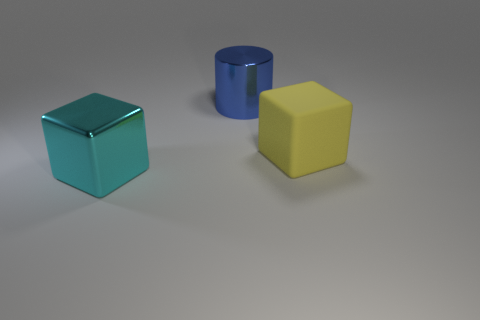Add 2 cylinders. How many objects exist? 5 Subtract all blocks. How many objects are left? 1 Add 1 big metallic cylinders. How many big metallic cylinders are left? 2 Add 3 large cylinders. How many large cylinders exist? 4 Subtract 0 brown blocks. How many objects are left? 3 Subtract all large yellow balls. Subtract all large yellow matte cubes. How many objects are left? 2 